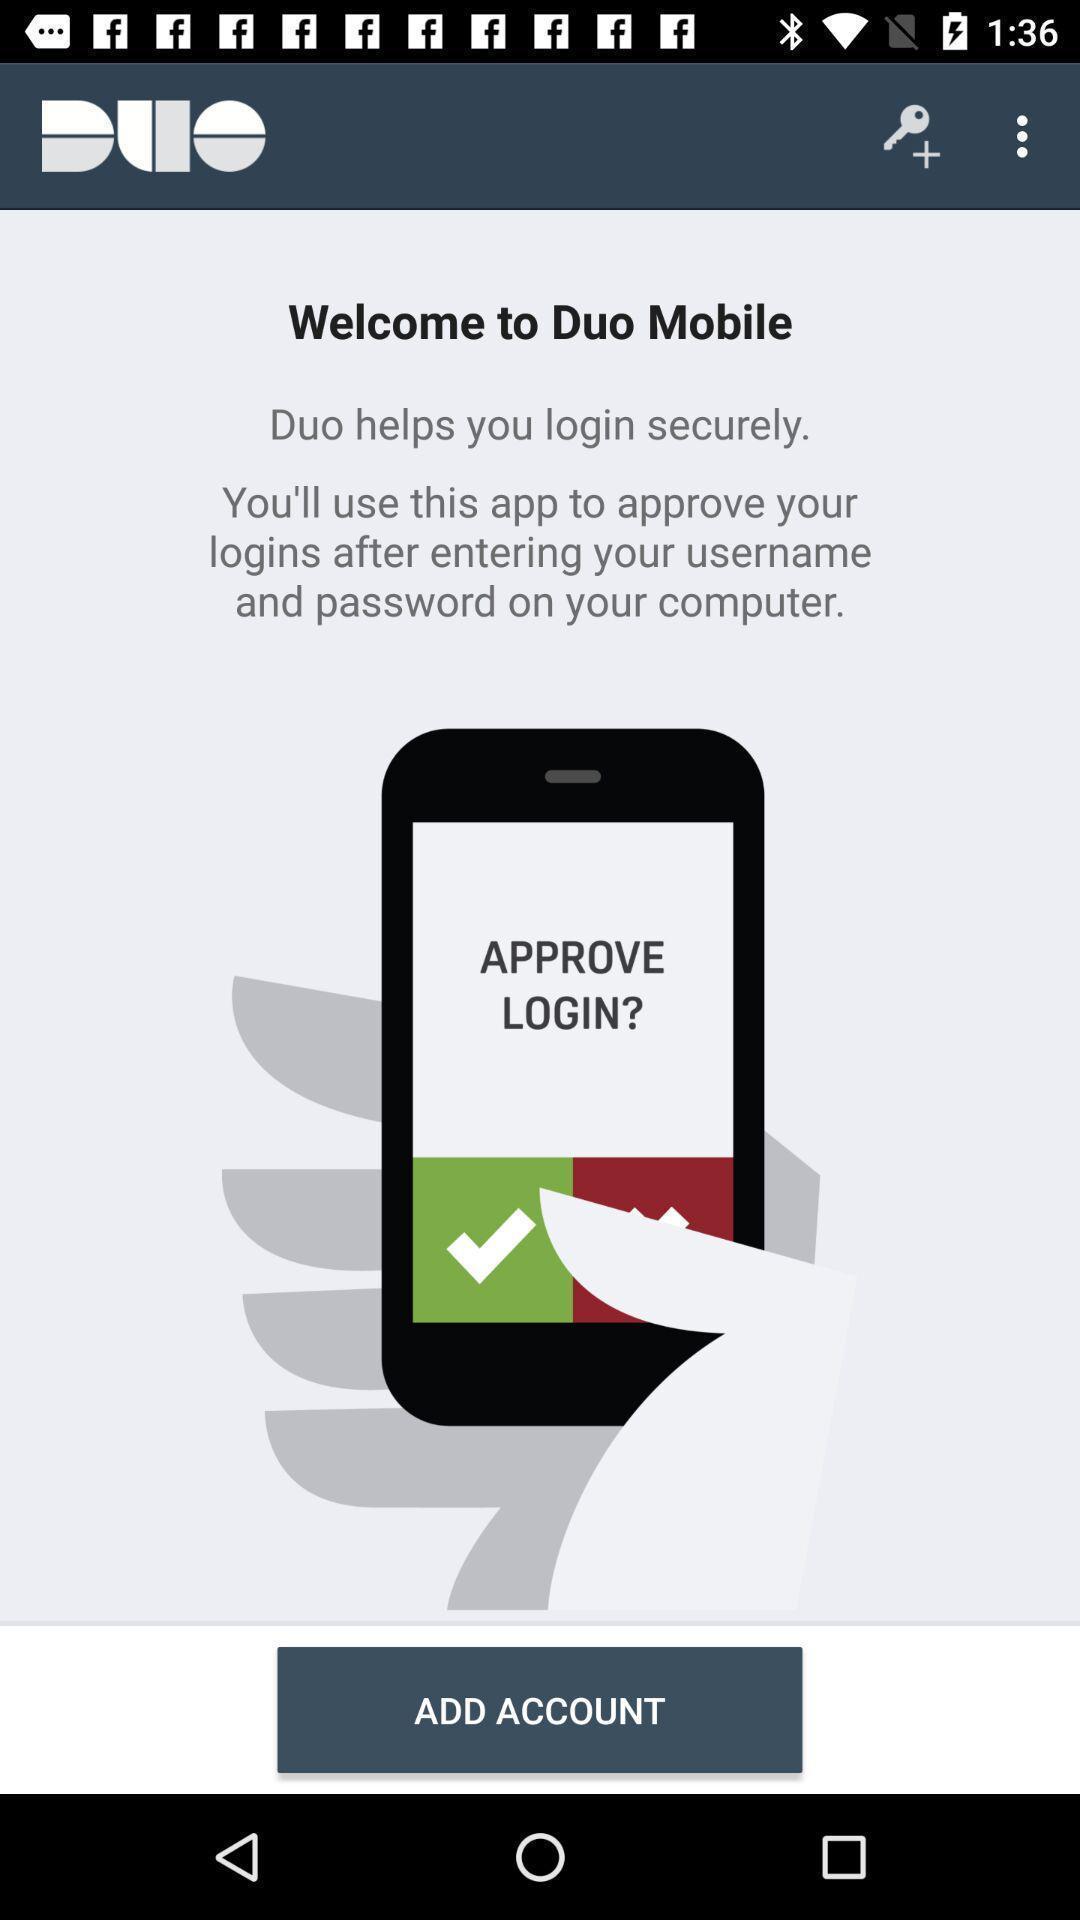Summarize the main components in this picture. Welcome page of an authentication app. 